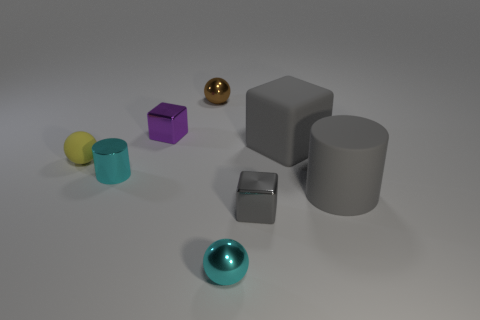Are there the same number of tiny things in front of the gray cylinder and brown cubes?
Offer a very short reply. No. There is a metal cylinder that is the same size as the yellow matte ball; what color is it?
Keep it short and to the point. Cyan. Are there any other tiny shiny things of the same shape as the gray metal object?
Ensure brevity in your answer.  Yes. There is a cylinder that is on the right side of the tiny block to the left of the cyan shiny thing in front of the big gray cylinder; what is its material?
Your answer should be very brief. Rubber. How many other things are there of the same size as the rubber sphere?
Provide a succinct answer. 5. The small matte sphere has what color?
Your answer should be compact. Yellow. What number of rubber objects are gray blocks or purple cubes?
Make the answer very short. 1. Is there any other thing that has the same material as the gray cylinder?
Offer a terse response. Yes. How big is the gray object that is behind the cyan thing that is behind the ball in front of the yellow rubber object?
Offer a very short reply. Large. What is the size of the ball that is right of the cyan cylinder and in front of the small brown metallic object?
Provide a succinct answer. Small. 